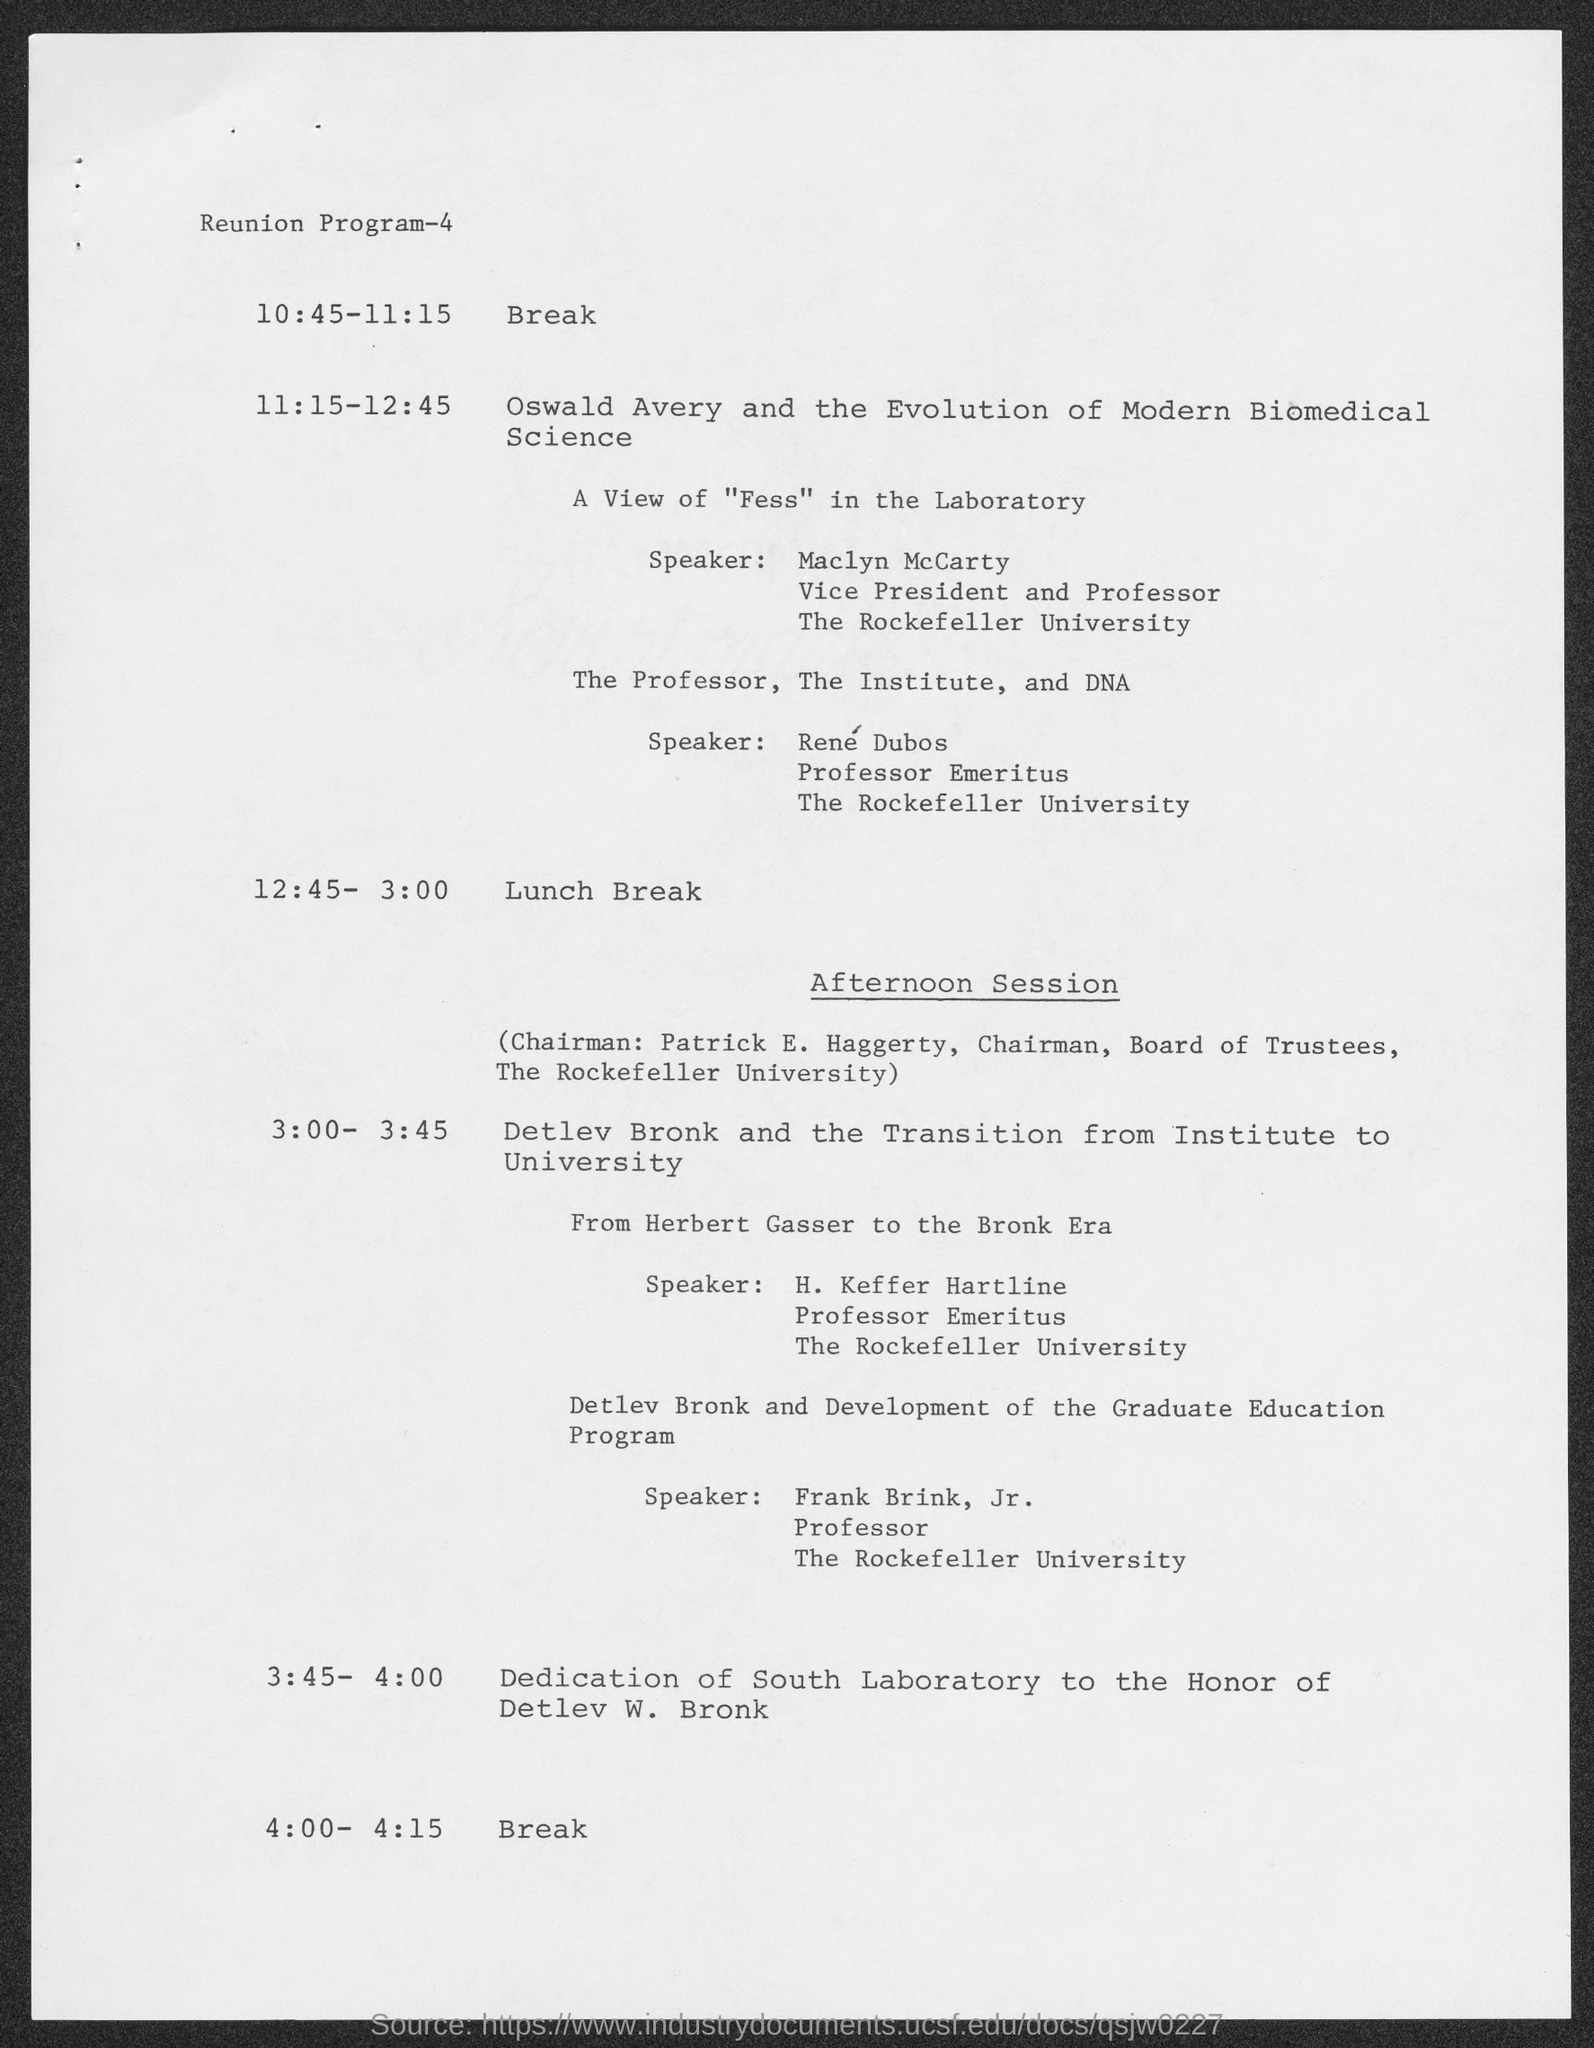Who is the speaker on a view of " fess" in the laboratory ?
Provide a succinct answer. Maclyn McCarty. To which university does maclyn  mccarty belong ?
Your answer should be very brief. The rockefeller university. 